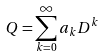Convert formula to latex. <formula><loc_0><loc_0><loc_500><loc_500>Q = \sum _ { k = 0 } ^ { \infty } a _ { k } D ^ { k }</formula> 